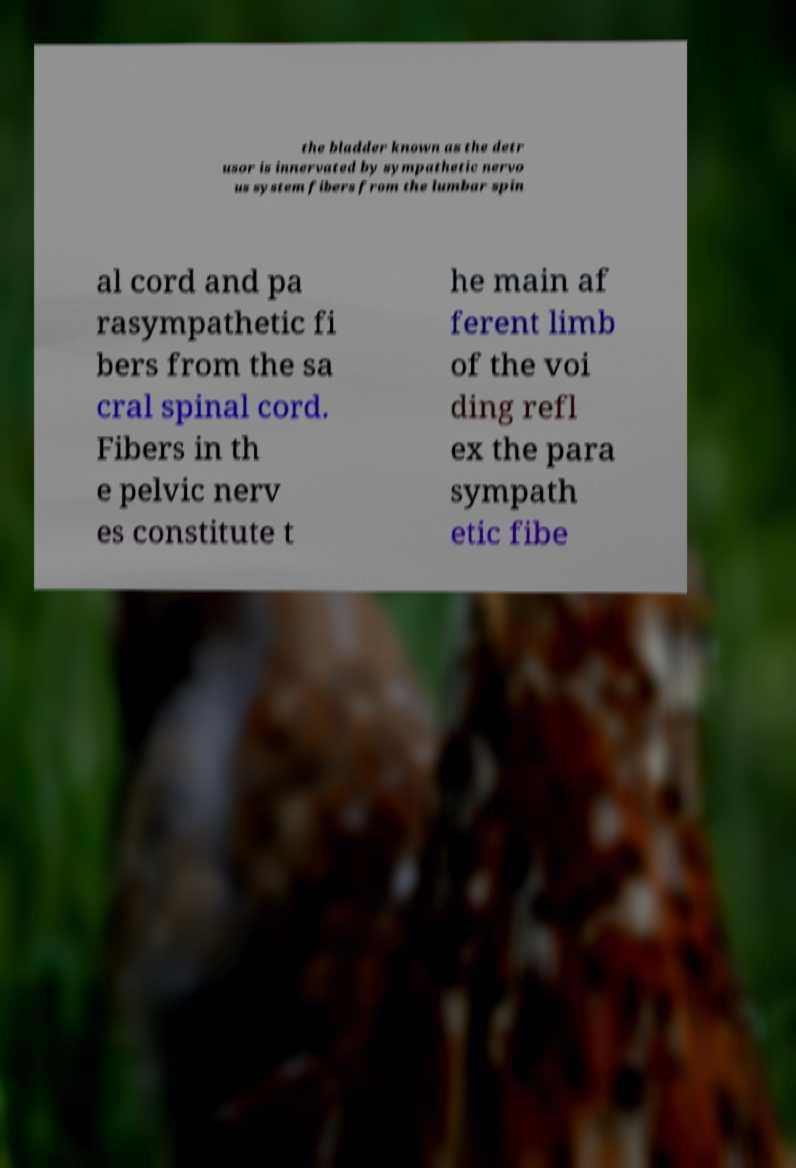Please identify and transcribe the text found in this image. the bladder known as the detr usor is innervated by sympathetic nervo us system fibers from the lumbar spin al cord and pa rasympathetic fi bers from the sa cral spinal cord. Fibers in th e pelvic nerv es constitute t he main af ferent limb of the voi ding refl ex the para sympath etic fibe 